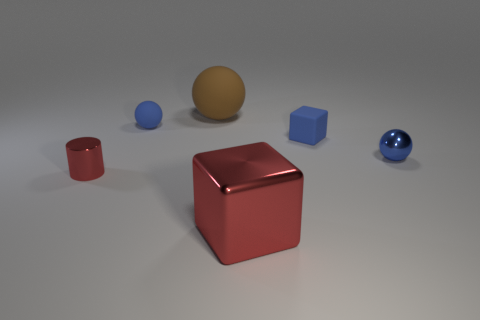Add 2 cylinders. How many objects exist? 8 Subtract all cubes. How many objects are left? 4 Subtract all small cubes. Subtract all large cyan things. How many objects are left? 5 Add 2 rubber spheres. How many rubber spheres are left? 4 Add 2 blue balls. How many blue balls exist? 4 Subtract 1 blue blocks. How many objects are left? 5 